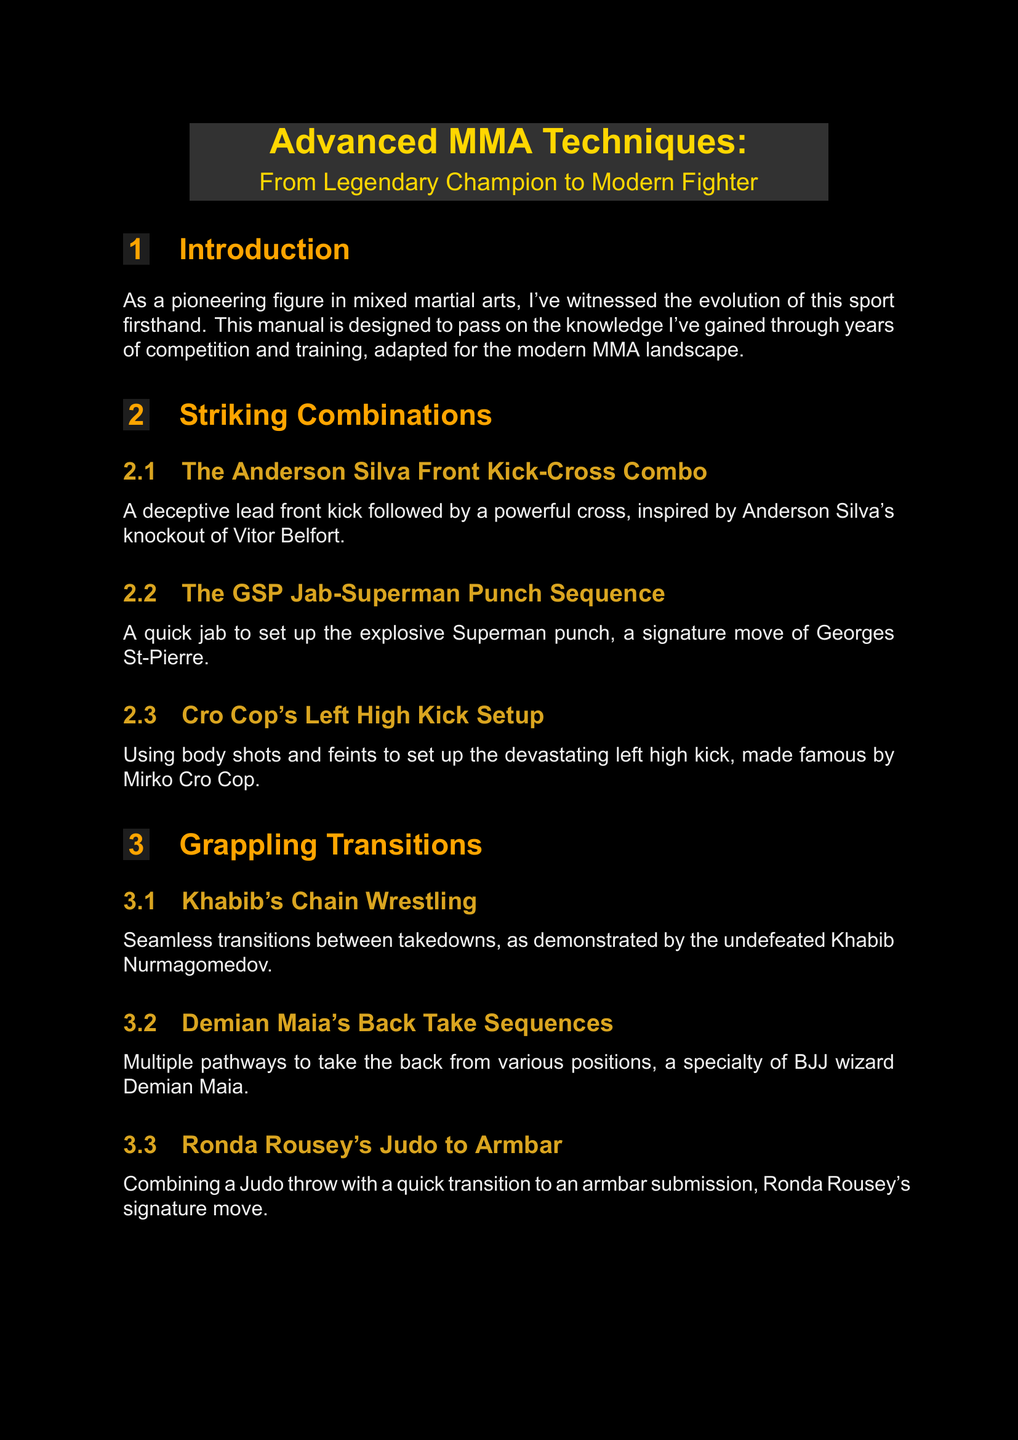What is the title of the manual? The title of the manual is stated at the beginning, which introduces its focus on advanced techniques in MMA.
Answer: Advanced MMA Techniques: From Legendary Champion to Modern Fighter Who inspired the front kick-cross combo? The document mentions specific fighters who inspire various techniques. In this case, the front kick-cross combo is inspired by Anderson Silva.
Answer: Anderson Silva What are "Muay Thai Plum Attacks"? This term is explained in the section on clinch work, where various striking techniques from the clinch position are detailed.
Answer: Devastating knee and elbow strikes from the Thai clinch Which fighter's technique focuses on “Game Planning”? The document presents various fighters associated with specific techniques, and “Game Planning” is attributed to Georges St-Pierre.
Answer: Georges St-Pierre How many sections are there in the manual? The document outlines different sections, and counting them gives the total for the manual.
Answer: Eight What type of training does Fedor Emelianenko focus on? The description under physical conditioning specifies the training type that Fedor Emelianenko emphasizes.
Answer: Explosive Power Training What does Ronda Rousey combine her Judo throw with? The manual describes a specific technique associated with Ronda Rousey and mentions what follows her Judo throw.
Answer: Armbar submission What is the purpose of visualization techniques according to the manual? The section on mental preparation discusses the function of visualization in performance and confidence enhancement.
Answer: Enhance performance and confidence 